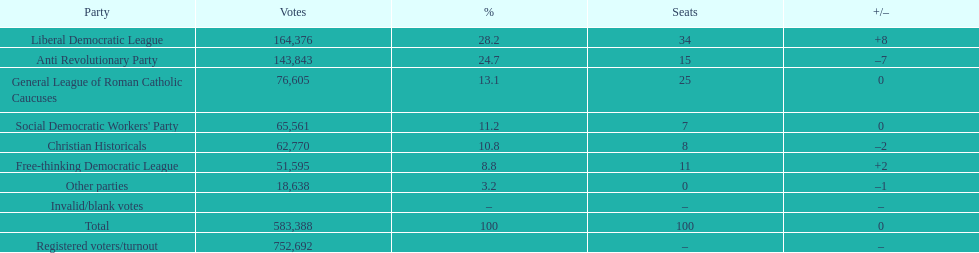After the election, how many seats did the liberal democratic league win? 34. 